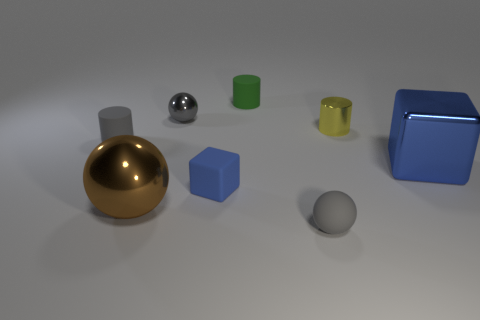Subtract 1 cylinders. How many cylinders are left? 2 Add 1 tiny green matte objects. How many objects exist? 9 Subtract all cylinders. How many objects are left? 5 Add 5 blue rubber things. How many blue rubber things exist? 6 Subtract 0 purple cylinders. How many objects are left? 8 Subtract all yellow cylinders. Subtract all big brown metal balls. How many objects are left? 6 Add 7 tiny gray rubber cylinders. How many tiny gray rubber cylinders are left? 8 